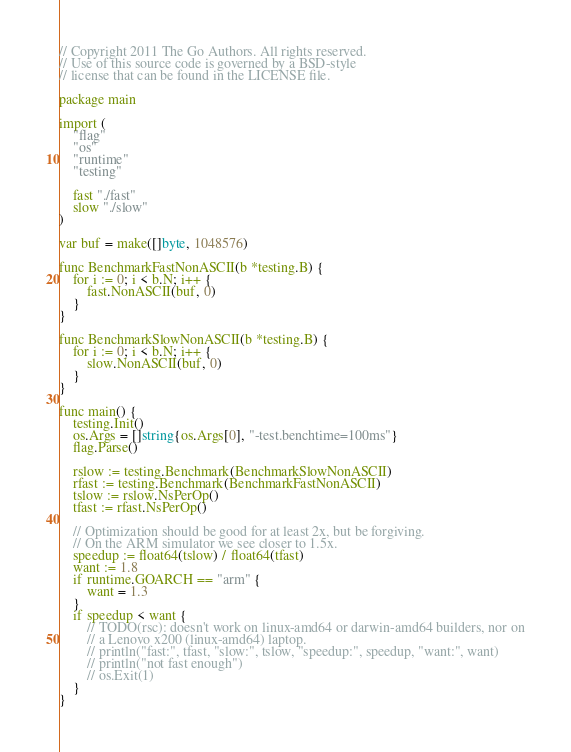Convert code to text. <code><loc_0><loc_0><loc_500><loc_500><_Go_>// Copyright 2011 The Go Authors. All rights reserved.
// Use of this source code is governed by a BSD-style
// license that can be found in the LICENSE file.

package main

import (
	"flag"
	"os"
	"runtime"
	"testing"

	fast "./fast"
	slow "./slow"
)

var buf = make([]byte, 1048576)

func BenchmarkFastNonASCII(b *testing.B) {
	for i := 0; i < b.N; i++ {
		fast.NonASCII(buf, 0)
	}
}

func BenchmarkSlowNonASCII(b *testing.B) {
	for i := 0; i < b.N; i++ {
		slow.NonASCII(buf, 0)
	}
}

func main() {
	testing.Init()
	os.Args = []string{os.Args[0], "-test.benchtime=100ms"}
	flag.Parse()

	rslow := testing.Benchmark(BenchmarkSlowNonASCII)
	rfast := testing.Benchmark(BenchmarkFastNonASCII)
	tslow := rslow.NsPerOp()
	tfast := rfast.NsPerOp()

	// Optimization should be good for at least 2x, but be forgiving.
	// On the ARM simulator we see closer to 1.5x.
	speedup := float64(tslow) / float64(tfast)
	want := 1.8
	if runtime.GOARCH == "arm" {
		want = 1.3
	}
	if speedup < want {
		// TODO(rsc): doesn't work on linux-amd64 or darwin-amd64 builders, nor on
		// a Lenovo x200 (linux-amd64) laptop.
		// println("fast:", tfast, "slow:", tslow, "speedup:", speedup, "want:", want)
		// println("not fast enough")
		// os.Exit(1)
	}
}
</code> 